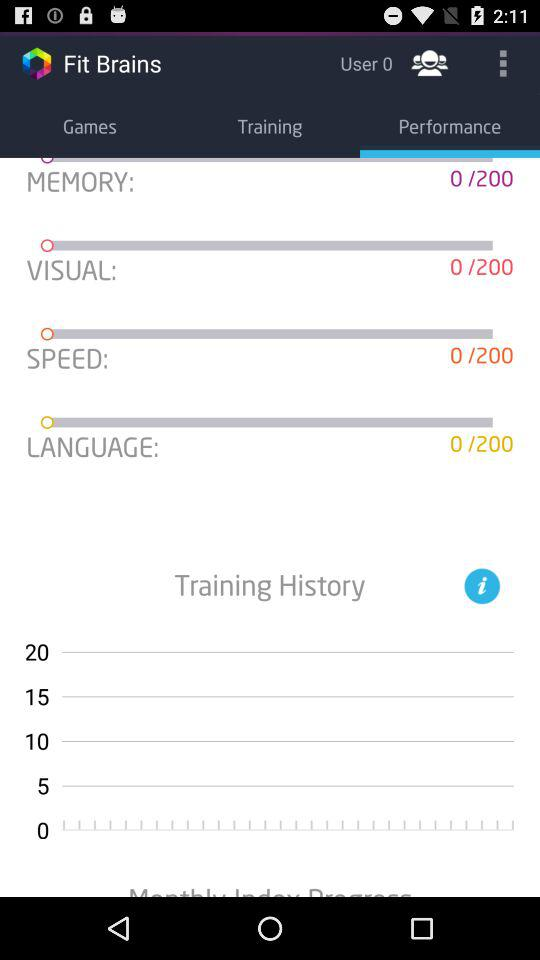How many training categories are there?
Answer the question using a single word or phrase. 4 